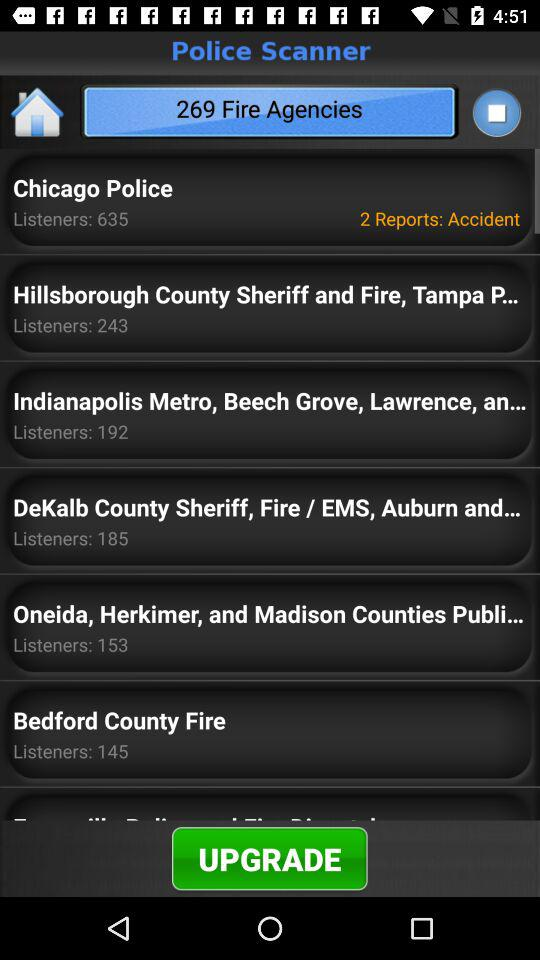How many listeners are there for "Bedford County Fire"? There are 145 listeners. 